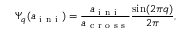Convert formula to latex. <formula><loc_0><loc_0><loc_500><loc_500>\Psi _ { q } ( a _ { i n i } ) = \frac { a _ { i n i } } { a _ { c r o s s } } \frac { \sin ( 2 \pi q ) } { 2 \pi } ,</formula> 